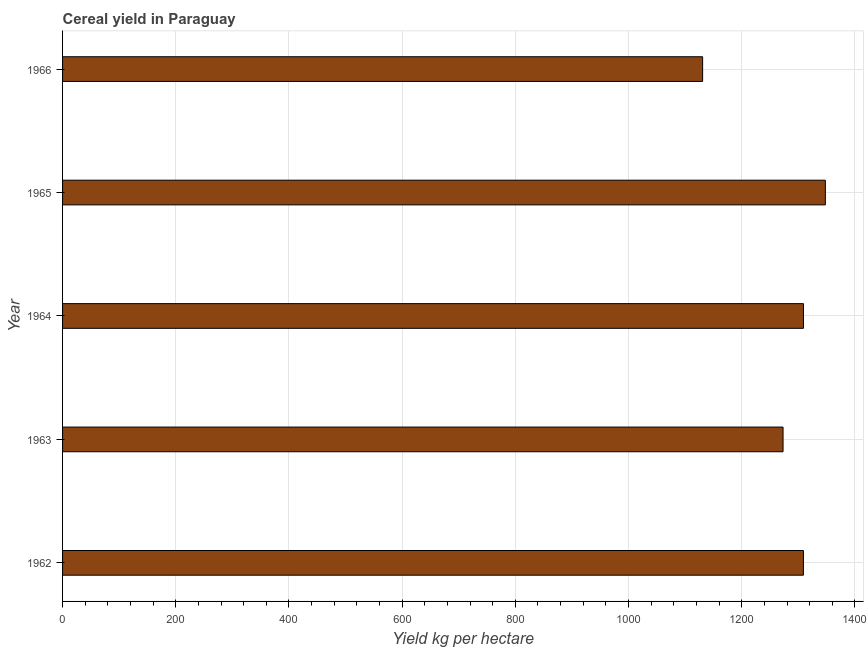What is the title of the graph?
Give a very brief answer. Cereal yield in Paraguay. What is the label or title of the X-axis?
Offer a very short reply. Yield kg per hectare. What is the cereal yield in 1966?
Give a very brief answer. 1130.94. Across all years, what is the maximum cereal yield?
Offer a very short reply. 1347.78. Across all years, what is the minimum cereal yield?
Offer a terse response. 1130.94. In which year was the cereal yield maximum?
Offer a very short reply. 1965. In which year was the cereal yield minimum?
Your answer should be very brief. 1966. What is the sum of the cereal yield?
Make the answer very short. 6369.86. What is the difference between the cereal yield in 1964 and 1966?
Offer a terse response. 178.13. What is the average cereal yield per year?
Provide a succinct answer. 1273.97. What is the median cereal yield?
Keep it short and to the point. 1309.03. In how many years, is the cereal yield greater than 400 kg per hectare?
Your answer should be very brief. 5. What is the ratio of the cereal yield in 1963 to that in 1966?
Ensure brevity in your answer.  1.13. Is the cereal yield in 1963 less than that in 1965?
Make the answer very short. Yes. What is the difference between the highest and the second highest cereal yield?
Your answer should be very brief. 38.71. Is the sum of the cereal yield in 1963 and 1966 greater than the maximum cereal yield across all years?
Offer a very short reply. Yes. What is the difference between the highest and the lowest cereal yield?
Make the answer very short. 216.84. How many years are there in the graph?
Keep it short and to the point. 5. What is the difference between two consecutive major ticks on the X-axis?
Offer a terse response. 200. Are the values on the major ticks of X-axis written in scientific E-notation?
Offer a terse response. No. What is the Yield kg per hectare of 1962?
Provide a short and direct response. 1309.03. What is the Yield kg per hectare of 1963?
Your answer should be compact. 1273.04. What is the Yield kg per hectare of 1964?
Your answer should be very brief. 1309.07. What is the Yield kg per hectare of 1965?
Your response must be concise. 1347.78. What is the Yield kg per hectare of 1966?
Offer a very short reply. 1130.94. What is the difference between the Yield kg per hectare in 1962 and 1963?
Your response must be concise. 35.99. What is the difference between the Yield kg per hectare in 1962 and 1964?
Provide a short and direct response. -0.04. What is the difference between the Yield kg per hectare in 1962 and 1965?
Make the answer very short. -38.75. What is the difference between the Yield kg per hectare in 1962 and 1966?
Your response must be concise. 178.09. What is the difference between the Yield kg per hectare in 1963 and 1964?
Give a very brief answer. -36.03. What is the difference between the Yield kg per hectare in 1963 and 1965?
Provide a short and direct response. -74.74. What is the difference between the Yield kg per hectare in 1963 and 1966?
Offer a very short reply. 142.1. What is the difference between the Yield kg per hectare in 1964 and 1965?
Your answer should be compact. -38.71. What is the difference between the Yield kg per hectare in 1964 and 1966?
Offer a very short reply. 178.13. What is the difference between the Yield kg per hectare in 1965 and 1966?
Your response must be concise. 216.84. What is the ratio of the Yield kg per hectare in 1962 to that in 1963?
Your response must be concise. 1.03. What is the ratio of the Yield kg per hectare in 1962 to that in 1965?
Your response must be concise. 0.97. What is the ratio of the Yield kg per hectare in 1962 to that in 1966?
Your response must be concise. 1.16. What is the ratio of the Yield kg per hectare in 1963 to that in 1965?
Provide a succinct answer. 0.94. What is the ratio of the Yield kg per hectare in 1963 to that in 1966?
Keep it short and to the point. 1.13. What is the ratio of the Yield kg per hectare in 1964 to that in 1966?
Your response must be concise. 1.16. What is the ratio of the Yield kg per hectare in 1965 to that in 1966?
Provide a succinct answer. 1.19. 